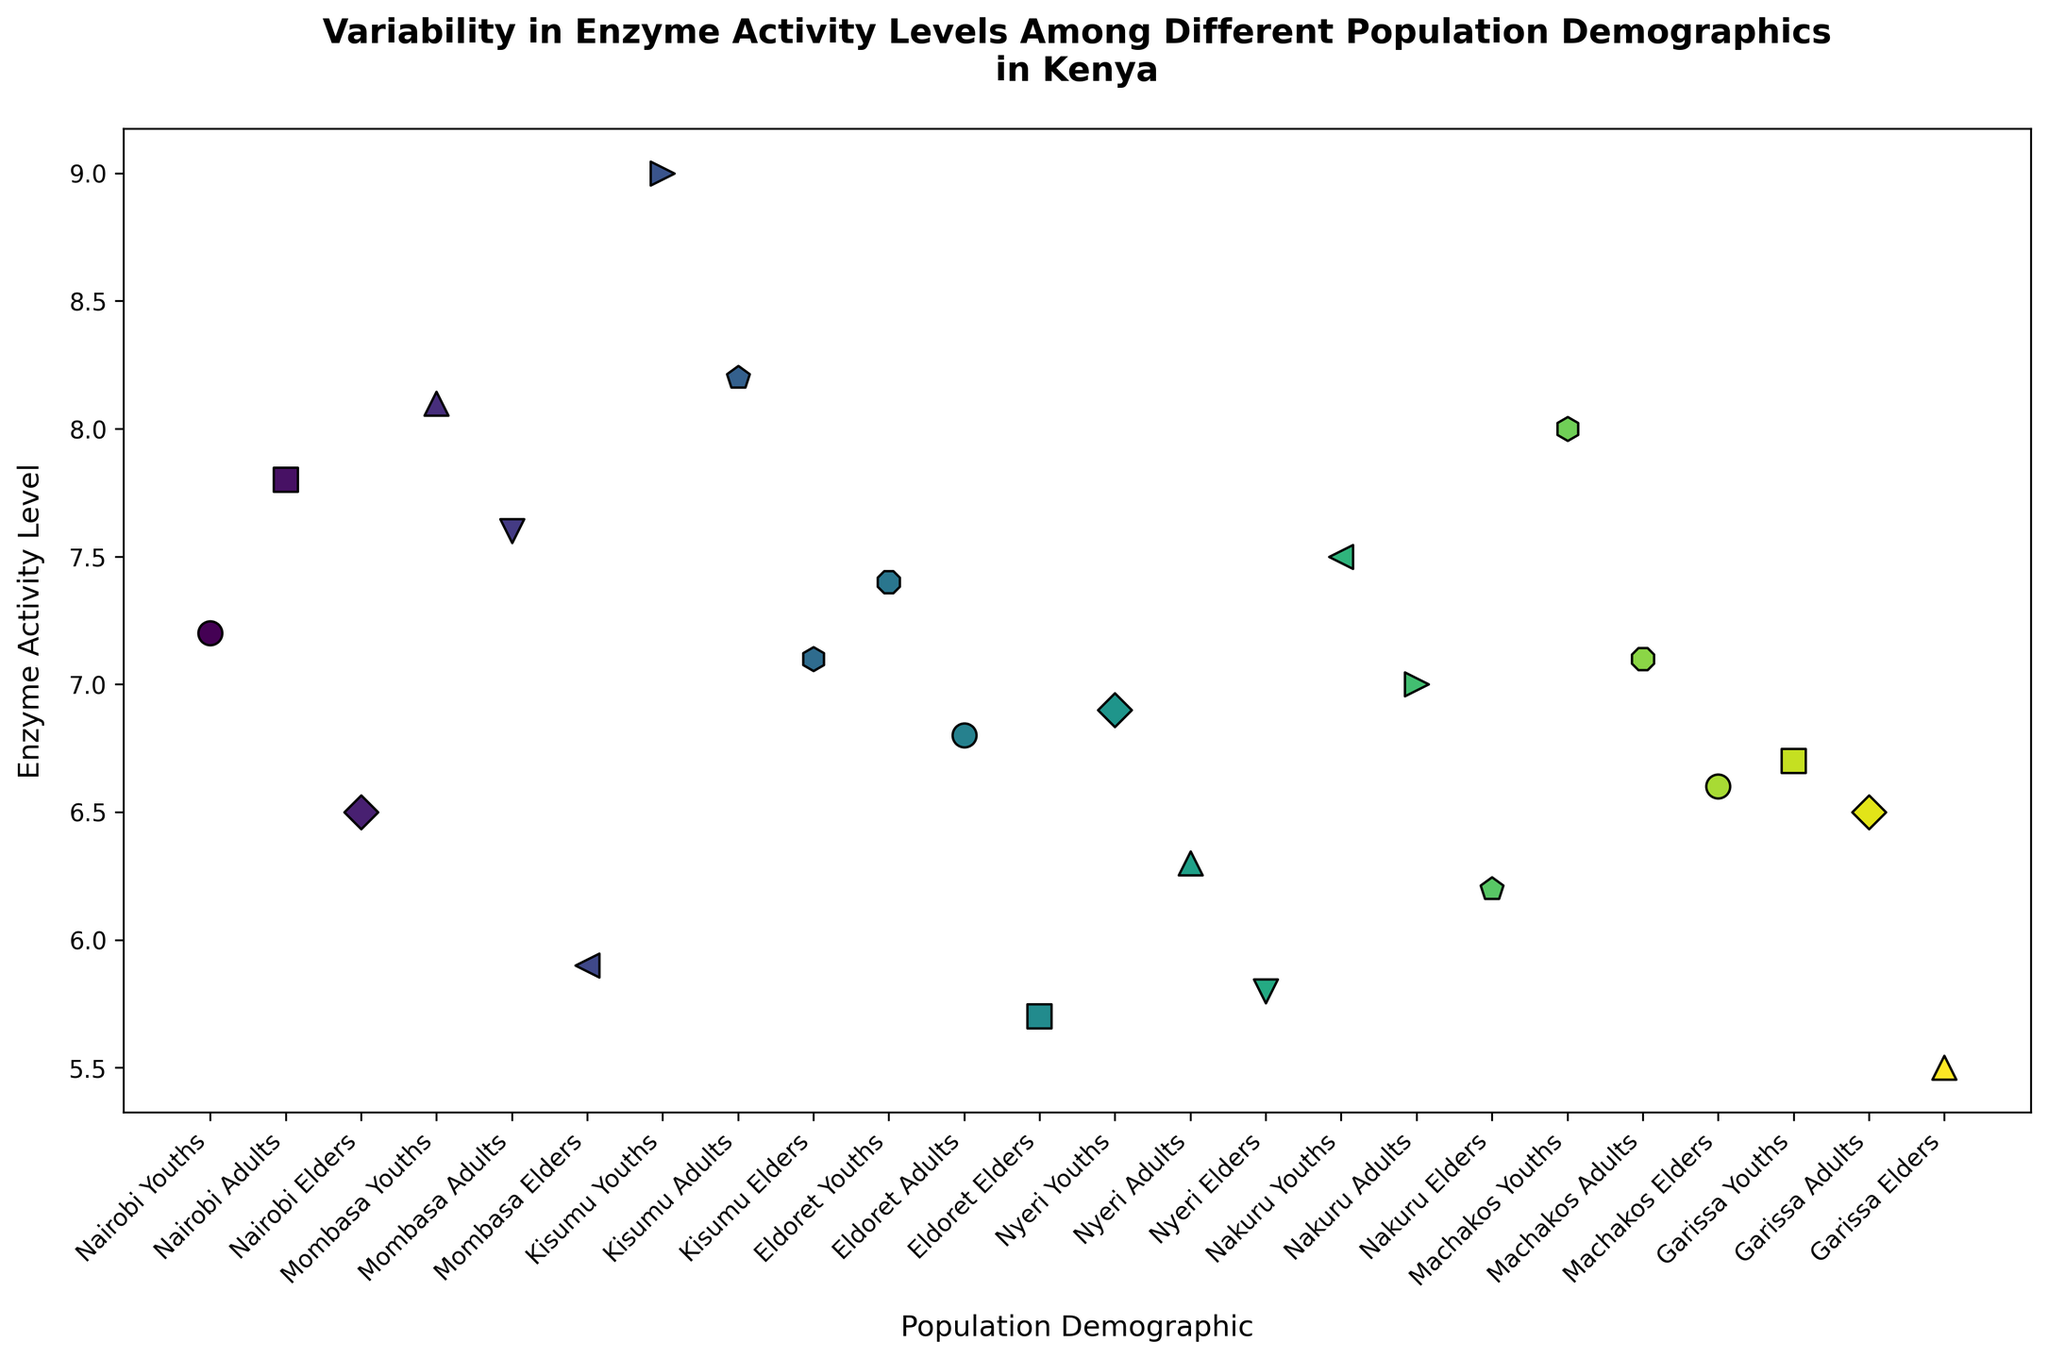What's the average enzyme activity level for elders across all demographics? First, locate the "elders" from all demographics in the scatter plot. Then sum up their enzyme activity levels: 6.5 (Nairobi) + 5.9 (Mombasa) + 7.1 (Kisumu) + 5.7 (Eldoret) + 5.8 (Nyeri) + 6.2 (Nakuru) + 6.6 (Machakos) + 5.5 (Garissa) = 49.3. Divide by the number of elder groups, which is 8. So, the average is 49.3 / 8 = 6.1625.
Answer: 6.16 Which demographic has the highest enzyme activity level? Identify the highest point on the y-axis (Enzyme Activity Level) among all demographics. The highest point corresponds to Kisumu Youths with an enzyme activity level of 9.0.
Answer: Kisumu Youths Is the enzyme activity level for Mombasa Elders higher or lower than for Eldoret Adults? Compare the y-values for Mombasa Elders (5.9) and Eldoret Adults (6.8). Mombasa Elders have a lower enzyme activity level than Eldoret Adults.
Answer: Lower What's the total enzyme activity level for Nairobi across all age groups? Add up the enzyme activity levels for Nairobi Youths (7.2), Nairobi Adults (7.8), and Nairobi Elders (6.5). The sum is 7.2 + 7.8 + 6.5 = 21.5.
Answer: 21.5 Among adults, which city has the lowest enzyme activity level? Compare the enzyme activity levels for adults in all cities: Nairobi (7.8), Mombasa (7.6), Kisumu (8.2), Eldoret (6.8), Nyeri (6.3), Nakuru (7.0), Machakos (7.1), and Garissa (6.5). Nyeri Adults have the lowest enzyme activity level of 6.3.
Answer: Nyeri Which demographic has the smallest range of enzyme activity levels between youths and elders? Calculate the range (difference between youths and elders) for each demographic. For example, Nairobi: 7.2 - 6.5 = 0.7, Mombasa: 8.1 - 5.9 = 2.2, Kisumu: 9.0 - 7.1 = 1.9, Eldoret: 7.4 - 5.7 = 1.7, Nyeri: 6.9 - 5.8 = 1.1, Nakuru: 7.5 - 6.2 = 1.3, Machakos: 8.0 - 6.6 = 1.4, Garissa: 6.7 - 5.5 = 1.2. Nairobi has the smallest range of 0.7.
Answer: Nairobi What’s the difference in enzyme activity levels between the youths of Nyeri and Kisumu? Identify the enzyme activity levels for Nyeri Youths (6.9) and Kisumu Youths (9.0). Calculate the difference: 9.0 - 6.9 = 2.1.
Answer: 2.1 